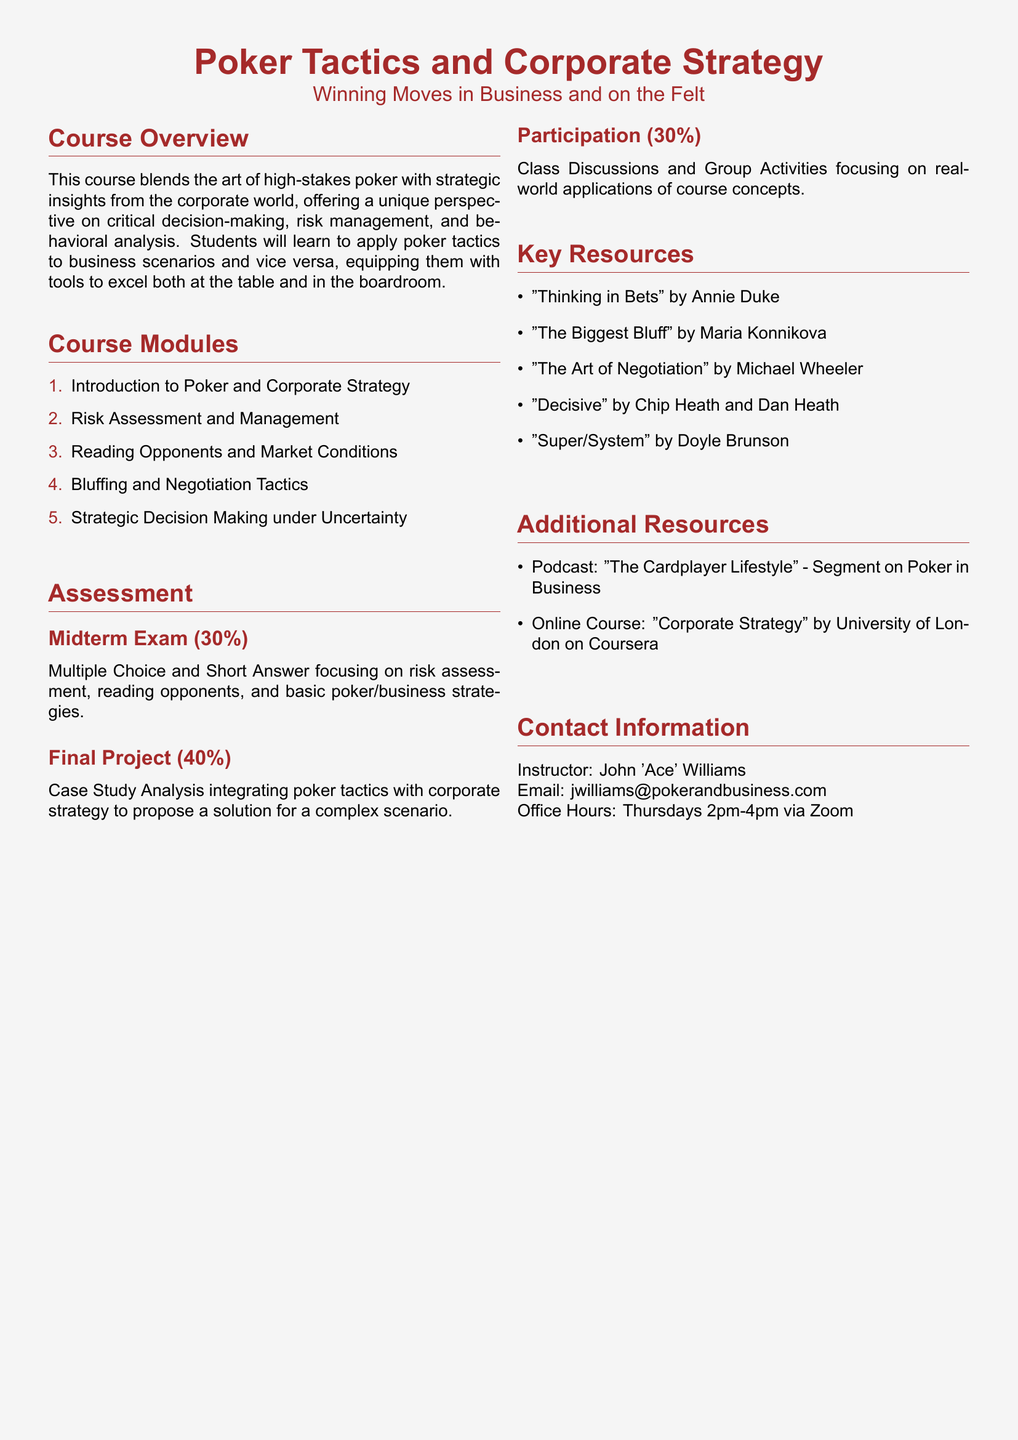What is the title of the course? The title is indicated at the beginning of the document, encapsulating the main theme of the syllabus.
Answer: Poker Tactics and Corporate Strategy Who is the instructor? The instructor's name is provided in the contact information section of the document.
Answer: John 'Ace' Williams What percentage is the Midterm Exam worth? The document specifies the weight of assessments, including the Midterm Exam.
Answer: 30% Name a book listed as a key resource. The key resources are listed, presenting various literature relevant to the course.
Answer: Thinking in Bets What is the focus of the Final Project? The Final Project description outlines its purpose in relation to the course content.
Answer: Case Study Analysis How many modules are there in the course? The total number of modules is mentioned in the course modules section.
Answer: 5 What is a topic covered in the course modules? The document outlines specific topics within the course modules, summarizing the course content.
Answer: Bluffing and Negotiation Tactics What is the email address provided for the instructor? The contact information section includes the instructor's email address.
Answer: jwilliams@pokerandbusiness.com 